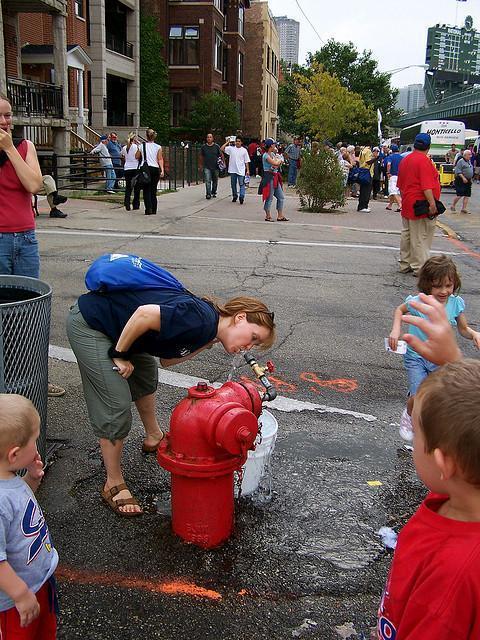How many people are there?
Give a very brief answer. 8. 